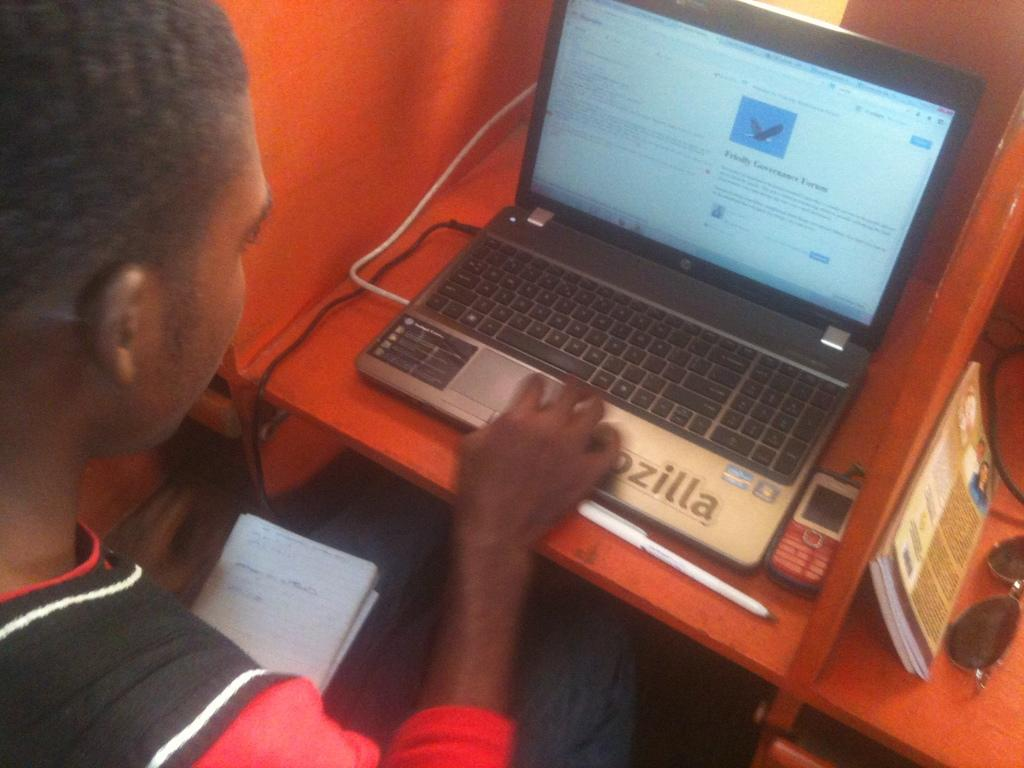<image>
Summarize the visual content of the image. A man works on his laptop computer with a forum on the screen. 